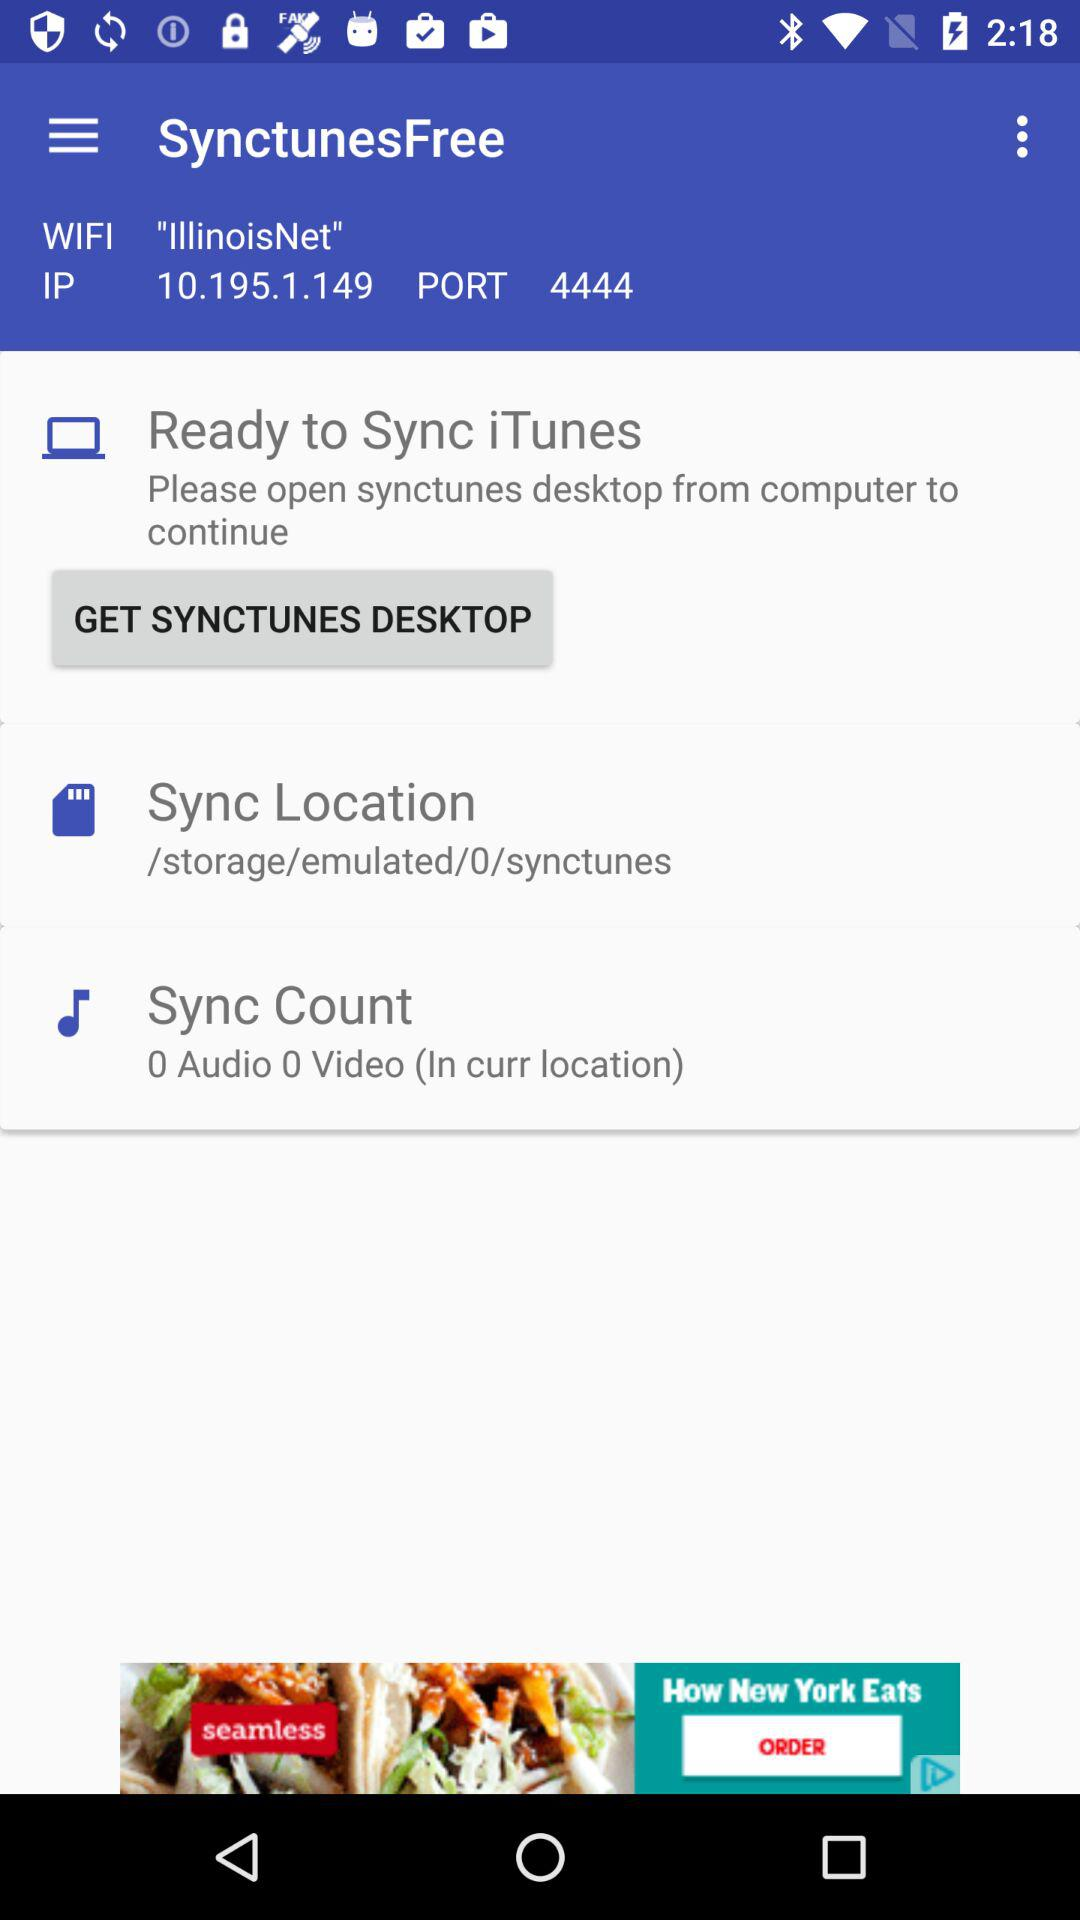How many audio files are in the current sync location?
Answer the question using a single word or phrase. 0 